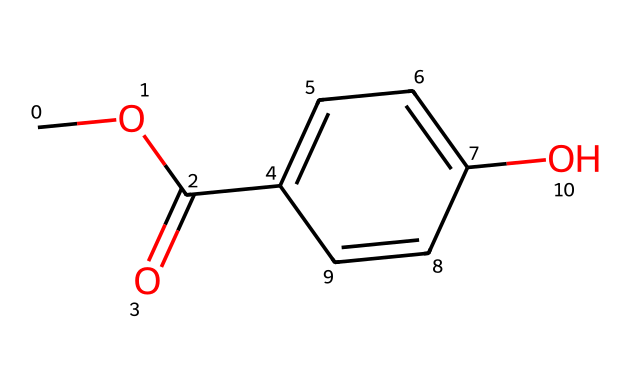What is the chemical name of this compound? The SMILES representation given corresponds to methylparaben, which is a commonly used paraben in skincare products. The structure shows a methyl group (–OCH₃) attached to a para-hydroxybenzoic acid moiety, confirming it as methylparaben.
Answer: methylparaben How many carbon atoms are present in the molecule? By analyzing the SMILES structure, we can count a total of 8 carbon atoms: 1 from the methyl group, and 7 from the aromatic and carbonyl portions of the structure.
Answer: 8 What type of chemical bond connects the carbonyl group to the benzene ring? The connection between the carbonyl (C=O) and the benzene ring in the structure is a carbon-to-carbon single bond (C–C) as indicated by the picture showing how the carbonyl directly links to a carbon atom in the aromatic system.
Answer: single bond What functional groups are present in this molecule? The structure shows two primary functional groups: an ester group (-C(=O)-O-) from the carbonyl, and a hydroxyl group (-OH) that characterizes the structure as a paraben, confirming it as an ester and alcohol combination.
Answer: ester and hydroxyl Which part of this molecule provides its preservative properties? The presence of the para-hydroxy group in the structure is essential for the antibacterial and antifungal activity, which are the attributes that confer the preservative properties of parabens in skincare products.
Answer: para-hydroxy group What is the total number of hydrogen atoms in this molecule? Analyzing the molecular structure, we see that there are 8 hydrogen atoms: 3 from the methyl group, 4 from the benzene ring, and 1 from the hydroxyl group indicating the full saturation of hydrogen around the carbon atoms.
Answer: 8 